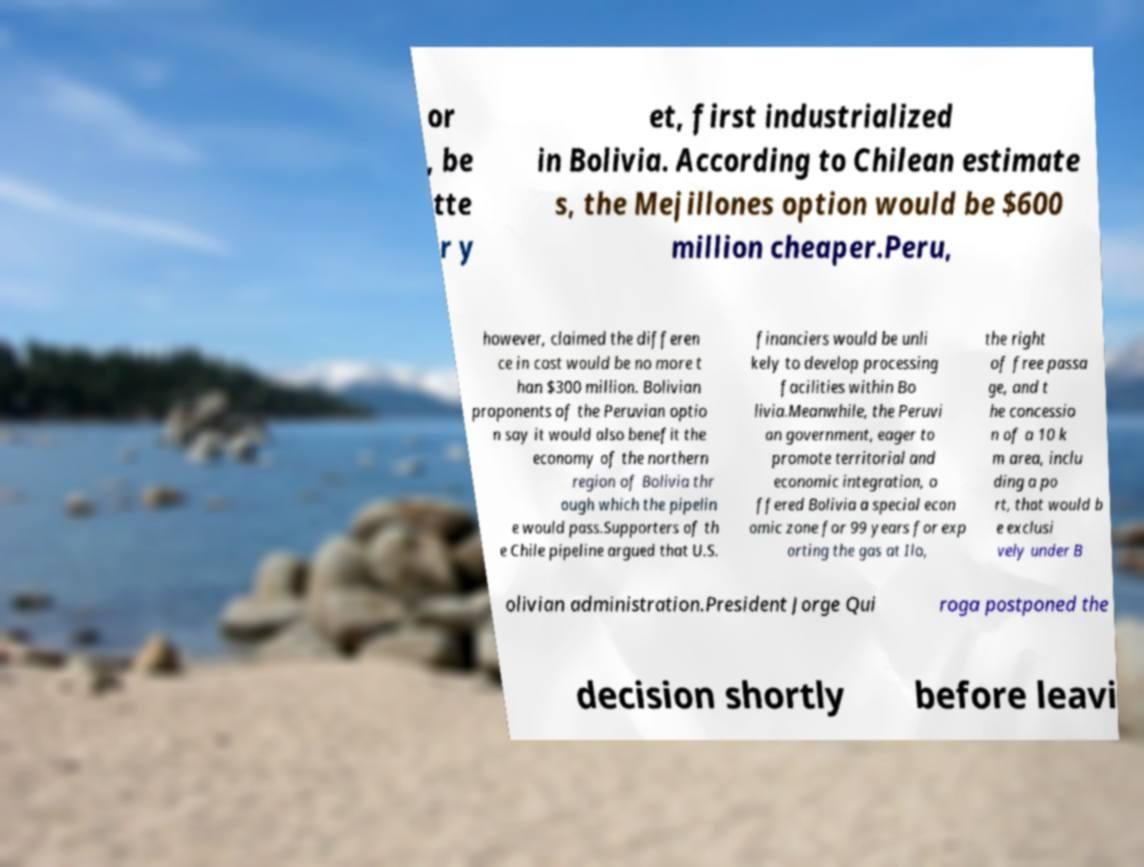For documentation purposes, I need the text within this image transcribed. Could you provide that? or , be tte r y et, first industrialized in Bolivia. According to Chilean estimate s, the Mejillones option would be $600 million cheaper.Peru, however, claimed the differen ce in cost would be no more t han $300 million. Bolivian proponents of the Peruvian optio n say it would also benefit the economy of the northern region of Bolivia thr ough which the pipelin e would pass.Supporters of th e Chile pipeline argued that U.S. financiers would be unli kely to develop processing facilities within Bo livia.Meanwhile, the Peruvi an government, eager to promote territorial and economic integration, o ffered Bolivia a special econ omic zone for 99 years for exp orting the gas at Ilo, the right of free passa ge, and t he concessio n of a 10 k m area, inclu ding a po rt, that would b e exclusi vely under B olivian administration.President Jorge Qui roga postponed the decision shortly before leavi 